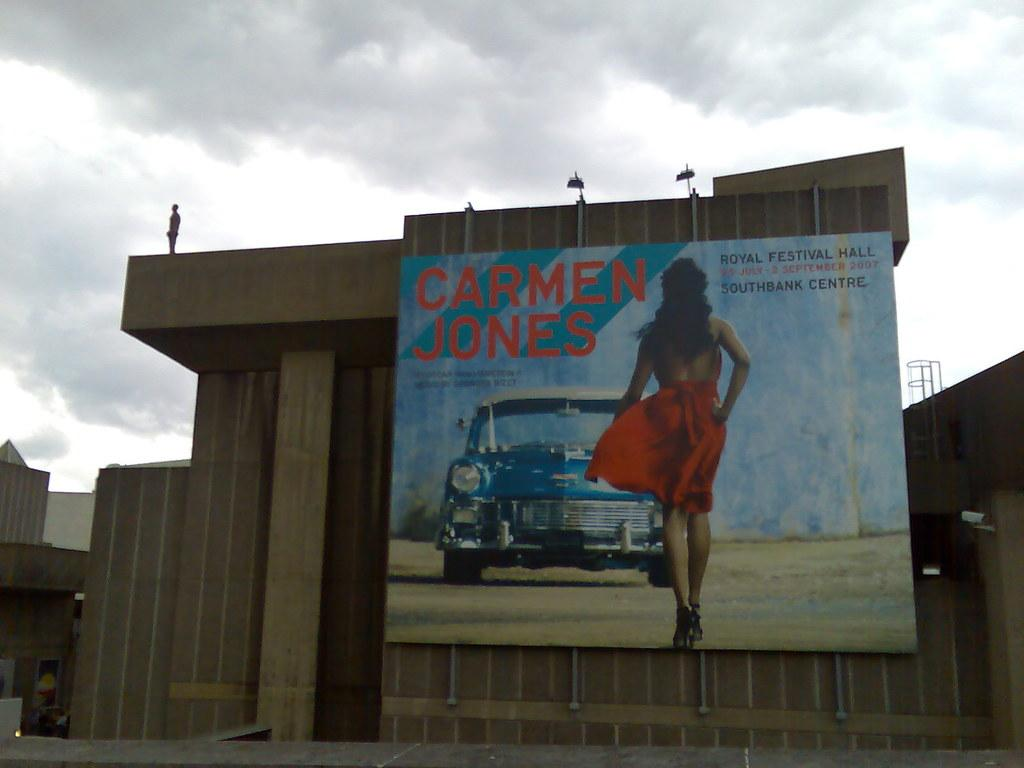<image>
Write a terse but informative summary of the picture. The poster on the wall has a photo of a car and is advertising a film starring Carmen Jones 